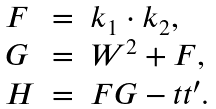Convert formula to latex. <formula><loc_0><loc_0><loc_500><loc_500>\begin{array} { l c l } F & = & k _ { 1 } \cdot k _ { 2 } , \\ G & = & W ^ { 2 } + F , \\ H & = & F G - t t ^ { \prime } . \end{array}</formula> 